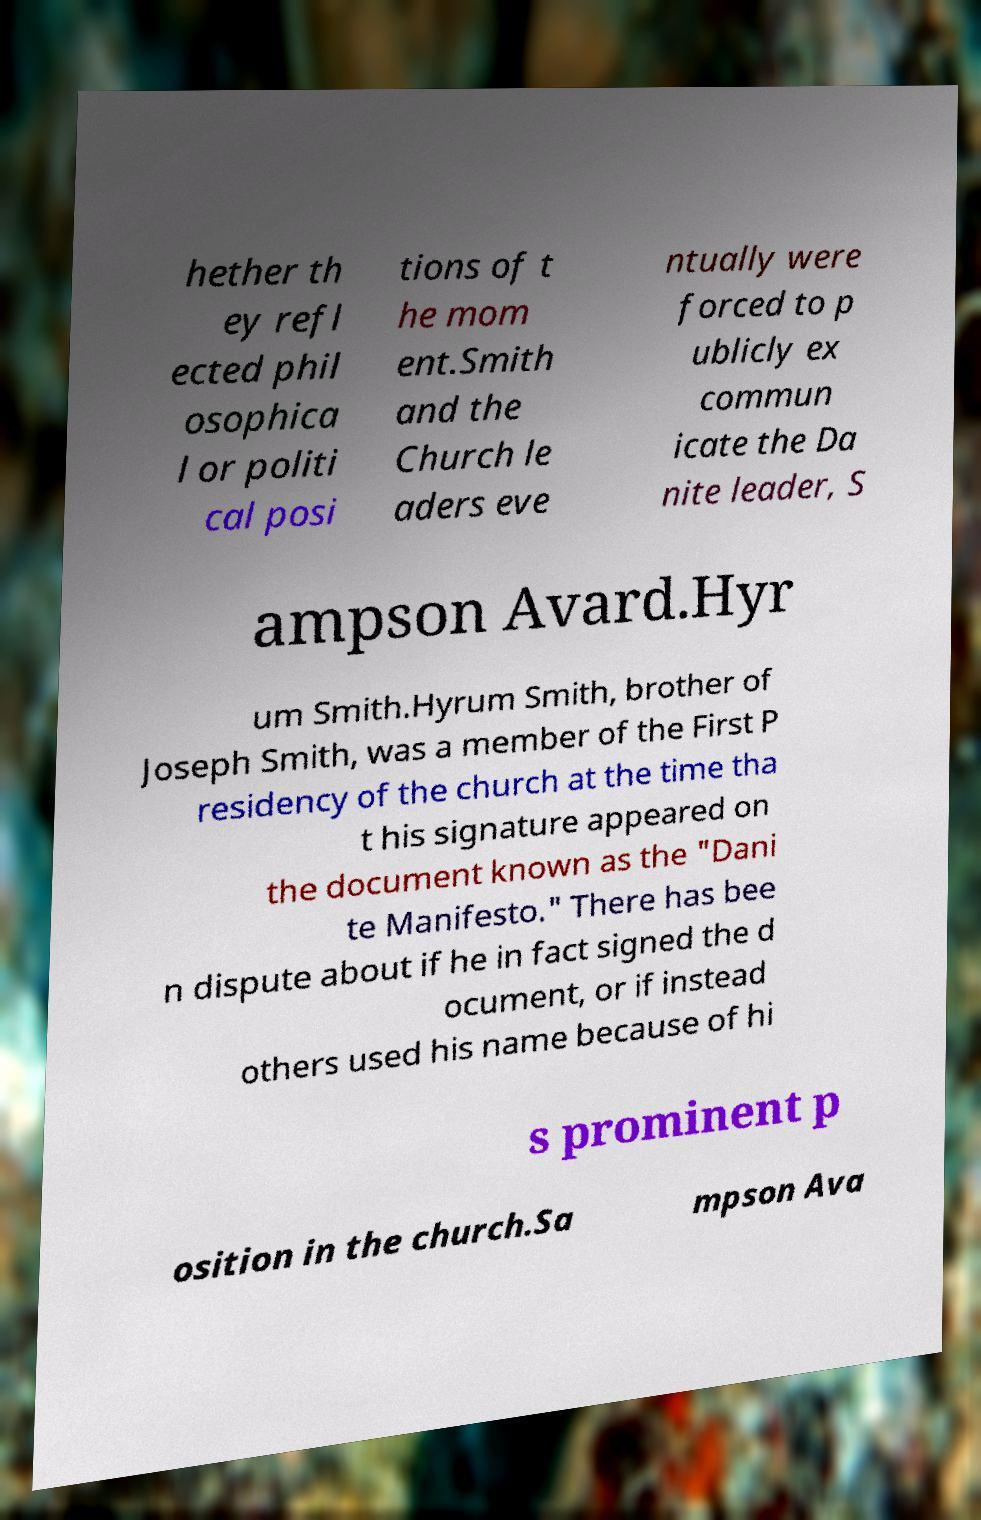Please read and relay the text visible in this image. What does it say? hether th ey refl ected phil osophica l or politi cal posi tions of t he mom ent.Smith and the Church le aders eve ntually were forced to p ublicly ex commun icate the Da nite leader, S ampson Avard.Hyr um Smith.Hyrum Smith, brother of Joseph Smith, was a member of the First P residency of the church at the time tha t his signature appeared on the document known as the "Dani te Manifesto." There has bee n dispute about if he in fact signed the d ocument, or if instead others used his name because of hi s prominent p osition in the church.Sa mpson Ava 